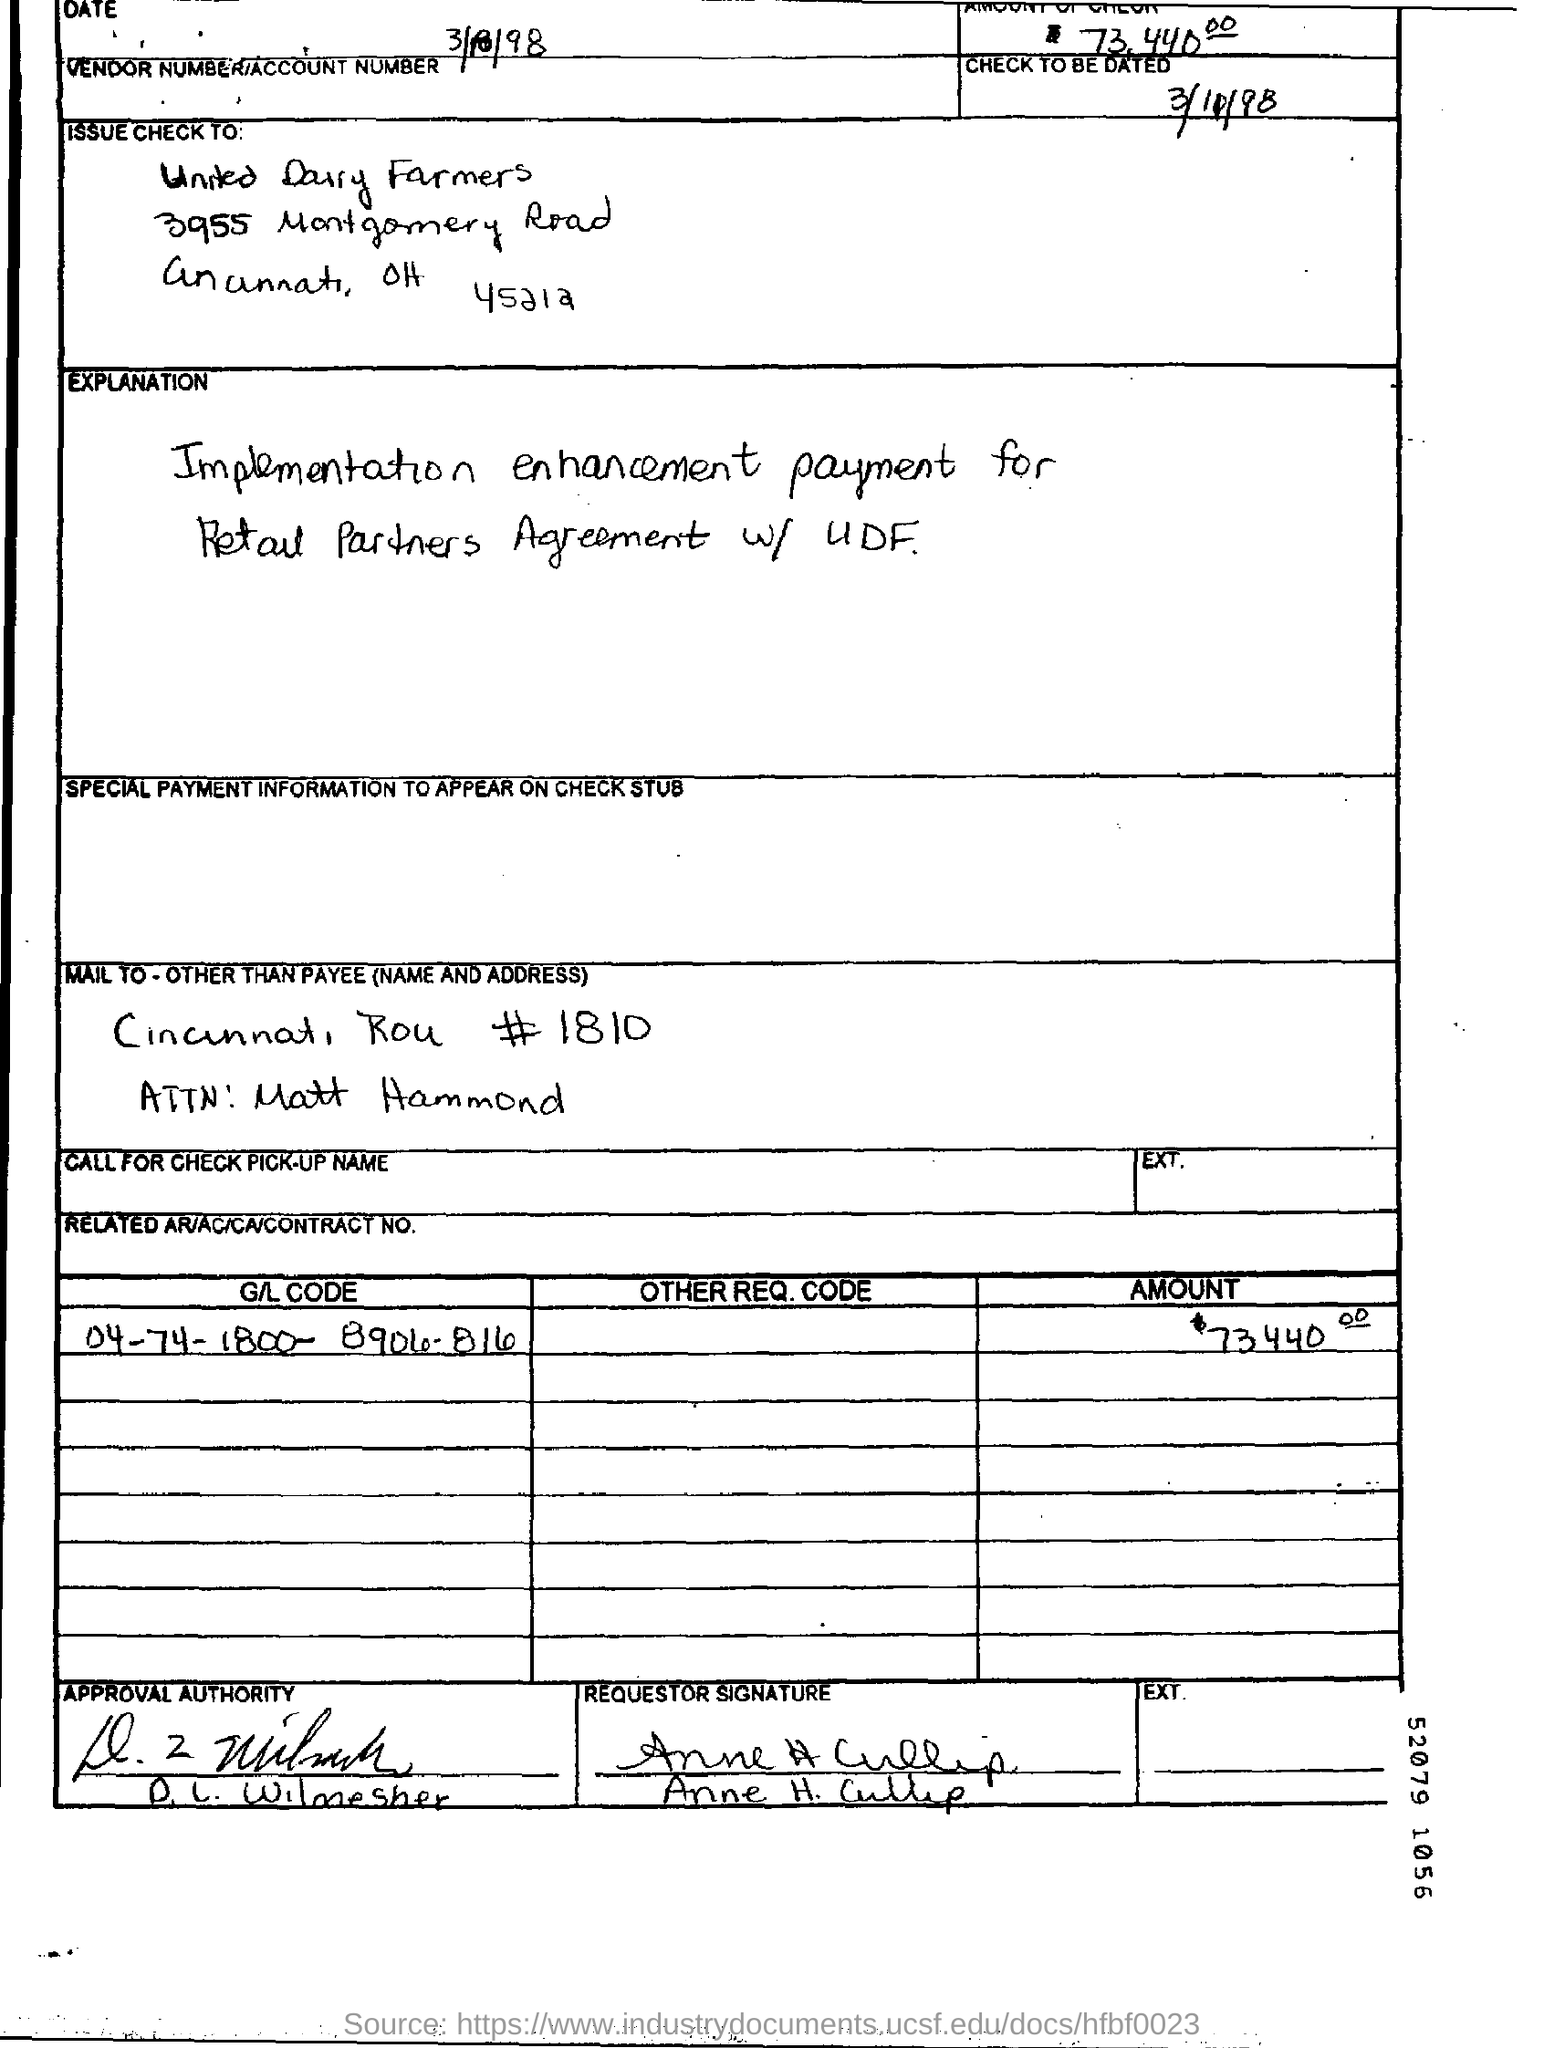Mention a couple of crucial points in this snapshot. The amount mentioned is 73,440... The G/L code is "04-74-1800-8904-816". 